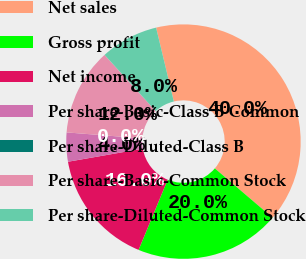Convert chart to OTSL. <chart><loc_0><loc_0><loc_500><loc_500><pie_chart><fcel>Net sales<fcel>Gross profit<fcel>Net income<fcel>Per share-Basic-Class B Common<fcel>Per share-Diluted-Class B<fcel>Per share-Basic-Common Stock<fcel>Per share-Diluted-Common Stock<nl><fcel>40.0%<fcel>20.0%<fcel>16.0%<fcel>4.0%<fcel>0.0%<fcel>12.0%<fcel>8.0%<nl></chart> 